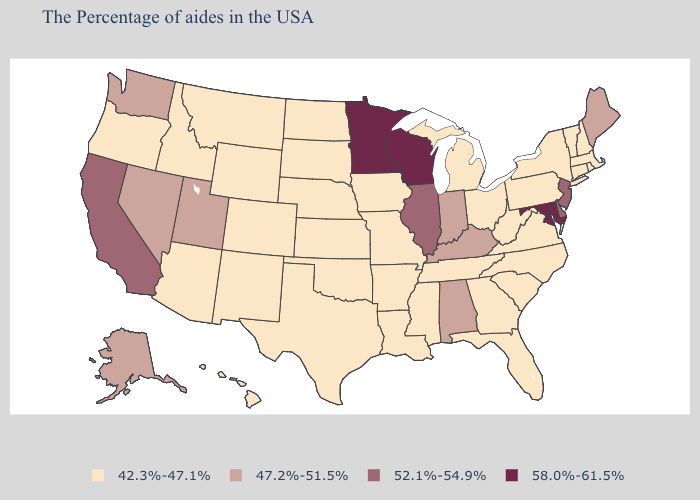How many symbols are there in the legend?
Keep it brief. 4. What is the highest value in states that border Virginia?
Be succinct. 58.0%-61.5%. Does New Hampshire have the lowest value in the USA?
Short answer required. Yes. Does Wisconsin have the highest value in the USA?
Short answer required. Yes. Does Arizona have a lower value than Texas?
Keep it brief. No. Does Michigan have the lowest value in the USA?
Write a very short answer. Yes. Is the legend a continuous bar?
Answer briefly. No. Among the states that border Montana , which have the lowest value?
Short answer required. South Dakota, North Dakota, Wyoming, Idaho. What is the value of Nevada?
Be succinct. 47.2%-51.5%. What is the value of Maryland?
Answer briefly. 58.0%-61.5%. Among the states that border Michigan , which have the lowest value?
Short answer required. Ohio. Is the legend a continuous bar?
Write a very short answer. No. What is the value of Ohio?
Give a very brief answer. 42.3%-47.1%. Name the states that have a value in the range 47.2%-51.5%?
Give a very brief answer. Maine, Kentucky, Indiana, Alabama, Utah, Nevada, Washington, Alaska. Which states have the lowest value in the USA?
Write a very short answer. Massachusetts, Rhode Island, New Hampshire, Vermont, Connecticut, New York, Pennsylvania, Virginia, North Carolina, South Carolina, West Virginia, Ohio, Florida, Georgia, Michigan, Tennessee, Mississippi, Louisiana, Missouri, Arkansas, Iowa, Kansas, Nebraska, Oklahoma, Texas, South Dakota, North Dakota, Wyoming, Colorado, New Mexico, Montana, Arizona, Idaho, Oregon, Hawaii. 